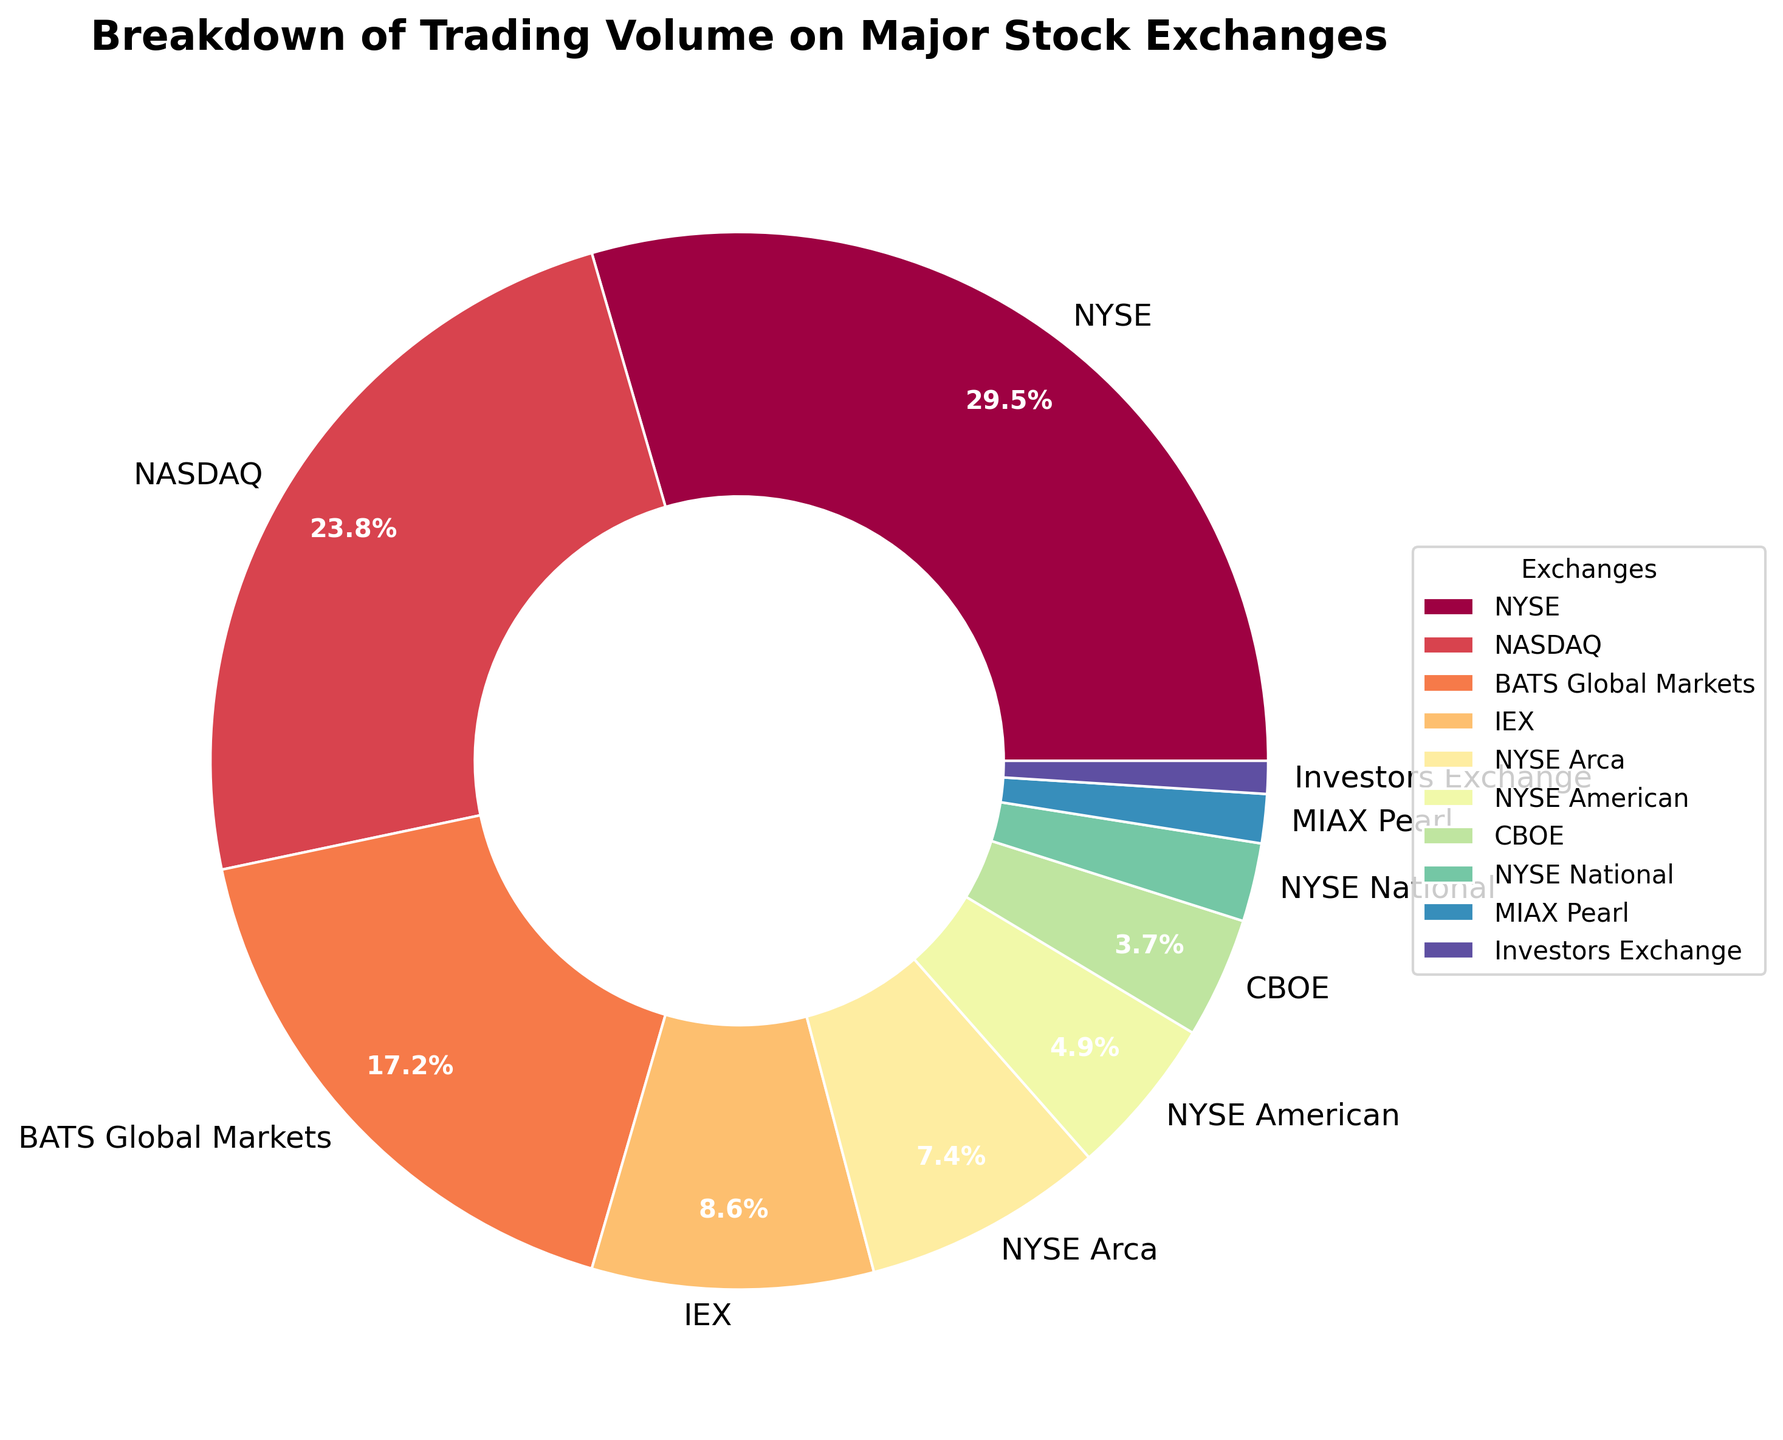Which stock exchange has the highest trading volume percentage? The largest wedge represents NYSE with a trading volume of 29.5%.
Answer: NYSE What is the combined trading volume percentage of NASDAQ and BATS Global Markets? The trading volumes for NASDAQ and BATS Global Markets are 23.8% and 17.2%. Adding them gives 23.8% + 17.2% = 41.0%.
Answer: 41.0% Which exchange has the smallest trading volume percentage, and what is it? The smallest wedge corresponds to Investors Exchange, which has a trading volume of 1.0%.
Answer: Investors Exchange, 1.0% Are there any exchanges with a trading volume percentage less than 5%? If so, which ones? The exchanges with wedges smaller than 5% are NYSE American, CBOE, NYSE National, MIAX Pearl, and Investors Exchange. Their respective trading volumes are 4.9%, 3.7%, 2.4%, 1.5%, and 1.0%.
Answer: NYSE American, CBOE, NYSE National, MIAX Pearl, Investors Exchange How much larger is the trading volume percentage of NYSE compared to NYSE Arca? NYSE has a trading volume of 29.5%, and NYSE Arca has 7.4%. The difference is 29.5% - 7.4% = 22.1%.
Answer: 22.1% What is the percentage difference between the exchange with the highest and lowest trading volumes? The highest is NYSE at 29.5% and the lowest is Investors Exchange at 1.0%. The difference is 29.5% - 1.0% = 28.5%.
Answer: 28.5% What is the combined trading volume percentage of the exchanges with more than 10% each? NYSE and NASDAQ both have trading volumes more than 10% (29.5% and 23.8%, respectively). Their combined trading volume is 29.5% + 23.8% = 53.3%.
Answer: 53.3% Which exchanges have a trading volume percentage represented by darker colors? Darker colors usually represent the larger values. Based on the figure attributes, NYSE and NASDAQ have the darkest colors with trading volumes of 29.5% and 23.8%, respectively.
Answer: NYSE, NASDAQ Do the combined trading volumes of IEX, NYSE Arca, and NYSE American exceed 20%? The trading volumes are IEX (8.6%), NYSE Arca (7.4%), and NYSE American (4.9%). Their combined total is 8.6% + 7.4% + 4.9% = 20.9%.
Answer: Yes, 20.9% Which exchanges have similar trading volumes, and what are their values? NYSE Arca (7.4%) and NYSE American (4.9%) have similar trading volumes relative to others, but not exactly equal. Other similar volumes are CBOE (3.7%) and NYSE National (2.4%).
Answer: NYSE Arca, NYSE American, CBOE, NYSE National 